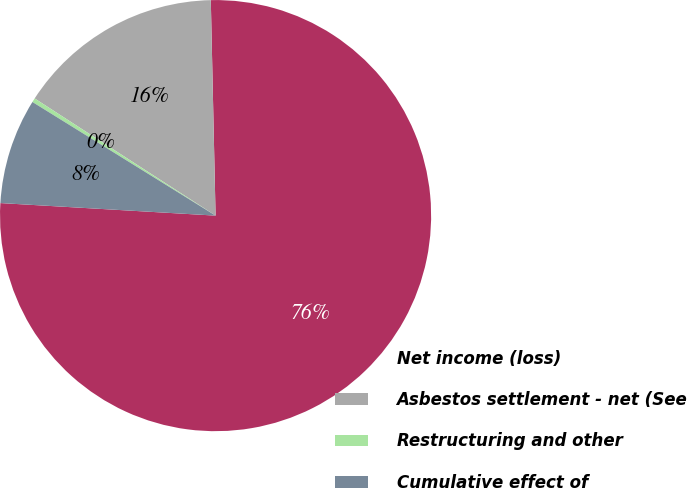<chart> <loc_0><loc_0><loc_500><loc_500><pie_chart><fcel>Net income (loss)<fcel>Asbestos settlement - net (See<fcel>Restructuring and other<fcel>Cumulative effect of<nl><fcel>76.28%<fcel>15.5%<fcel>0.31%<fcel>7.91%<nl></chart> 